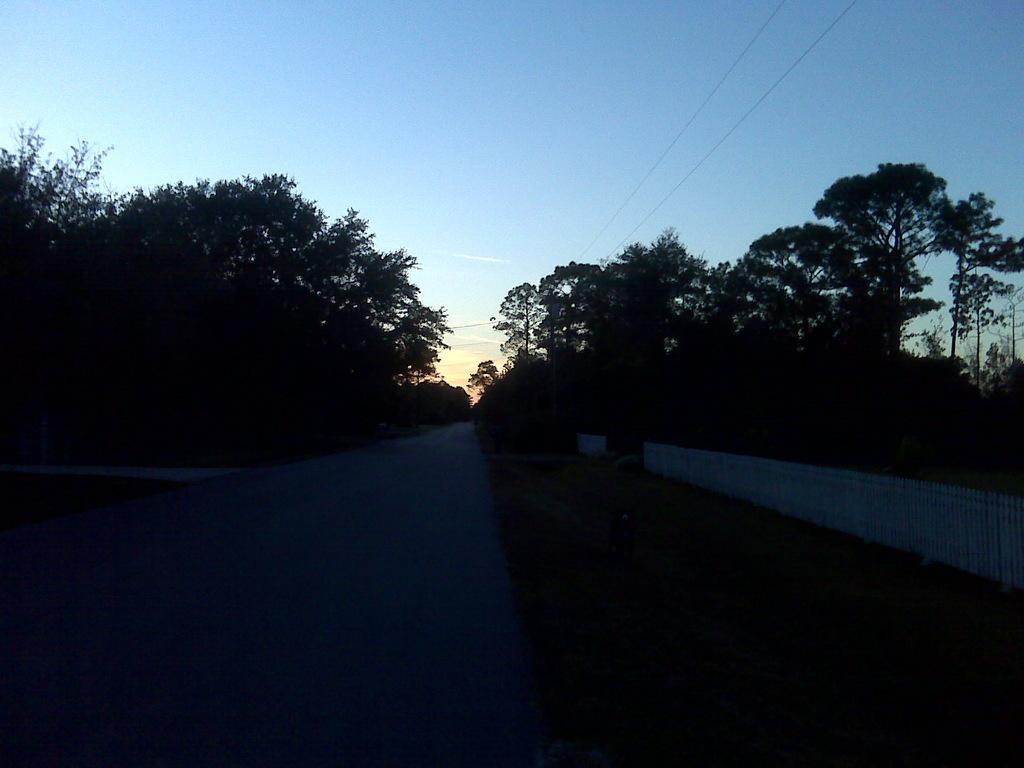Can you describe this image briefly? In the foreground of this image, there is a road. On the right, there is grass, railing, few trees and cables on the top. On the left, there are trees and on the top, there is the sky. 